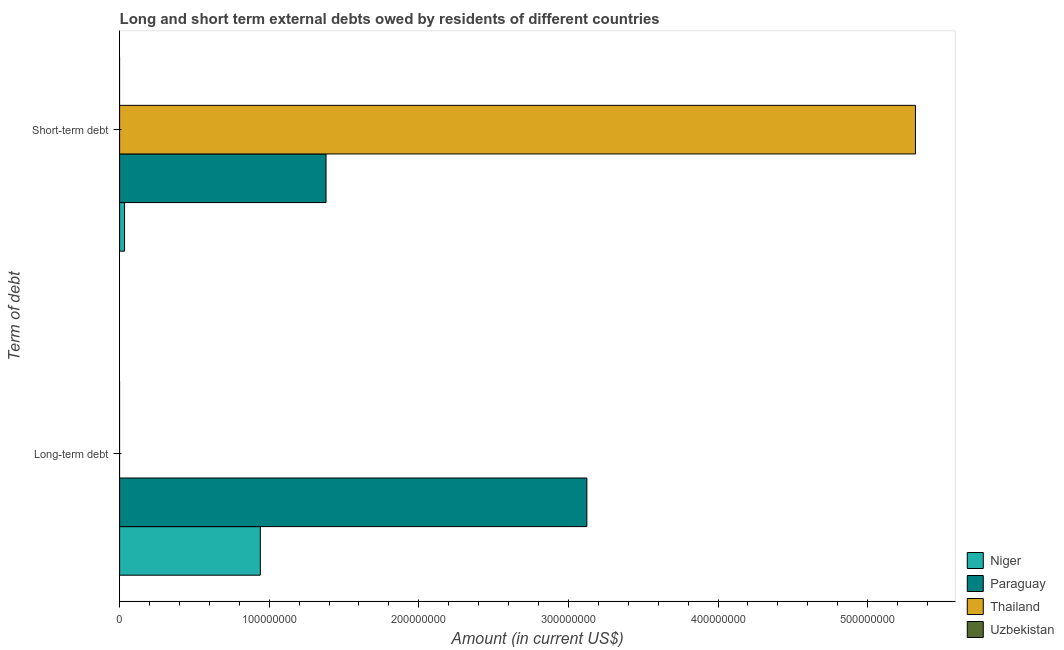Are the number of bars per tick equal to the number of legend labels?
Offer a terse response. No. Are the number of bars on each tick of the Y-axis equal?
Ensure brevity in your answer.  No. How many bars are there on the 1st tick from the bottom?
Ensure brevity in your answer.  2. What is the label of the 1st group of bars from the top?
Your response must be concise. Short-term debt. What is the long-term debts owed by residents in Uzbekistan?
Provide a short and direct response. 0. Across all countries, what is the maximum long-term debts owed by residents?
Your response must be concise. 3.12e+08. In which country was the long-term debts owed by residents maximum?
Make the answer very short. Paraguay. What is the total short-term debts owed by residents in the graph?
Keep it short and to the point. 6.73e+08. What is the difference between the long-term debts owed by residents in Paraguay and that in Niger?
Your answer should be very brief. 2.18e+08. What is the difference between the long-term debts owed by residents in Niger and the short-term debts owed by residents in Paraguay?
Offer a very short reply. -4.39e+07. What is the average long-term debts owed by residents per country?
Provide a succinct answer. 1.02e+08. What is the difference between the short-term debts owed by residents and long-term debts owed by residents in Paraguay?
Ensure brevity in your answer.  -1.74e+08. In how many countries, is the short-term debts owed by residents greater than 300000000 US$?
Your answer should be compact. 1. What is the ratio of the short-term debts owed by residents in Paraguay to that in Thailand?
Ensure brevity in your answer.  0.26. Are all the bars in the graph horizontal?
Offer a very short reply. Yes. What is the difference between two consecutive major ticks on the X-axis?
Ensure brevity in your answer.  1.00e+08. Are the values on the major ticks of X-axis written in scientific E-notation?
Offer a terse response. No. Does the graph contain any zero values?
Provide a succinct answer. Yes. Does the graph contain grids?
Your answer should be compact. No. Where does the legend appear in the graph?
Provide a succinct answer. Bottom right. How many legend labels are there?
Provide a succinct answer. 4. What is the title of the graph?
Offer a terse response. Long and short term external debts owed by residents of different countries. Does "Central Europe" appear as one of the legend labels in the graph?
Give a very brief answer. No. What is the label or title of the X-axis?
Provide a succinct answer. Amount (in current US$). What is the label or title of the Y-axis?
Provide a succinct answer. Term of debt. What is the Amount (in current US$) in Niger in Long-term debt?
Provide a succinct answer. 9.41e+07. What is the Amount (in current US$) in Paraguay in Long-term debt?
Offer a very short reply. 3.12e+08. What is the Amount (in current US$) in Thailand in Long-term debt?
Ensure brevity in your answer.  0. What is the Amount (in current US$) in Uzbekistan in Long-term debt?
Ensure brevity in your answer.  0. What is the Amount (in current US$) in Niger in Short-term debt?
Your response must be concise. 3.30e+06. What is the Amount (in current US$) of Paraguay in Short-term debt?
Provide a succinct answer. 1.38e+08. What is the Amount (in current US$) in Thailand in Short-term debt?
Give a very brief answer. 5.32e+08. Across all Term of debt, what is the maximum Amount (in current US$) in Niger?
Provide a short and direct response. 9.41e+07. Across all Term of debt, what is the maximum Amount (in current US$) of Paraguay?
Provide a short and direct response. 3.12e+08. Across all Term of debt, what is the maximum Amount (in current US$) of Thailand?
Make the answer very short. 5.32e+08. Across all Term of debt, what is the minimum Amount (in current US$) of Niger?
Offer a terse response. 3.30e+06. Across all Term of debt, what is the minimum Amount (in current US$) in Paraguay?
Your answer should be very brief. 1.38e+08. Across all Term of debt, what is the minimum Amount (in current US$) in Thailand?
Your answer should be very brief. 0. What is the total Amount (in current US$) of Niger in the graph?
Ensure brevity in your answer.  9.74e+07. What is the total Amount (in current US$) of Paraguay in the graph?
Provide a succinct answer. 4.50e+08. What is the total Amount (in current US$) of Thailand in the graph?
Give a very brief answer. 5.32e+08. What is the difference between the Amount (in current US$) in Niger in Long-term debt and that in Short-term debt?
Your answer should be compact. 9.08e+07. What is the difference between the Amount (in current US$) of Paraguay in Long-term debt and that in Short-term debt?
Ensure brevity in your answer.  1.74e+08. What is the difference between the Amount (in current US$) in Niger in Long-term debt and the Amount (in current US$) in Paraguay in Short-term debt?
Your answer should be very brief. -4.39e+07. What is the difference between the Amount (in current US$) of Niger in Long-term debt and the Amount (in current US$) of Thailand in Short-term debt?
Offer a very short reply. -4.38e+08. What is the difference between the Amount (in current US$) of Paraguay in Long-term debt and the Amount (in current US$) of Thailand in Short-term debt?
Offer a terse response. -2.20e+08. What is the average Amount (in current US$) of Niger per Term of debt?
Your response must be concise. 4.87e+07. What is the average Amount (in current US$) in Paraguay per Term of debt?
Offer a very short reply. 2.25e+08. What is the average Amount (in current US$) of Thailand per Term of debt?
Provide a short and direct response. 2.66e+08. What is the average Amount (in current US$) in Uzbekistan per Term of debt?
Offer a very short reply. 0. What is the difference between the Amount (in current US$) of Niger and Amount (in current US$) of Paraguay in Long-term debt?
Your answer should be very brief. -2.18e+08. What is the difference between the Amount (in current US$) in Niger and Amount (in current US$) in Paraguay in Short-term debt?
Your answer should be very brief. -1.35e+08. What is the difference between the Amount (in current US$) in Niger and Amount (in current US$) in Thailand in Short-term debt?
Provide a succinct answer. -5.29e+08. What is the difference between the Amount (in current US$) of Paraguay and Amount (in current US$) of Thailand in Short-term debt?
Give a very brief answer. -3.94e+08. What is the ratio of the Amount (in current US$) of Niger in Long-term debt to that in Short-term debt?
Keep it short and to the point. 28.46. What is the ratio of the Amount (in current US$) in Paraguay in Long-term debt to that in Short-term debt?
Your response must be concise. 2.26. What is the difference between the highest and the second highest Amount (in current US$) of Niger?
Keep it short and to the point. 9.08e+07. What is the difference between the highest and the second highest Amount (in current US$) in Paraguay?
Your answer should be compact. 1.74e+08. What is the difference between the highest and the lowest Amount (in current US$) of Niger?
Your answer should be very brief. 9.08e+07. What is the difference between the highest and the lowest Amount (in current US$) of Paraguay?
Provide a short and direct response. 1.74e+08. What is the difference between the highest and the lowest Amount (in current US$) of Thailand?
Your answer should be compact. 5.32e+08. 